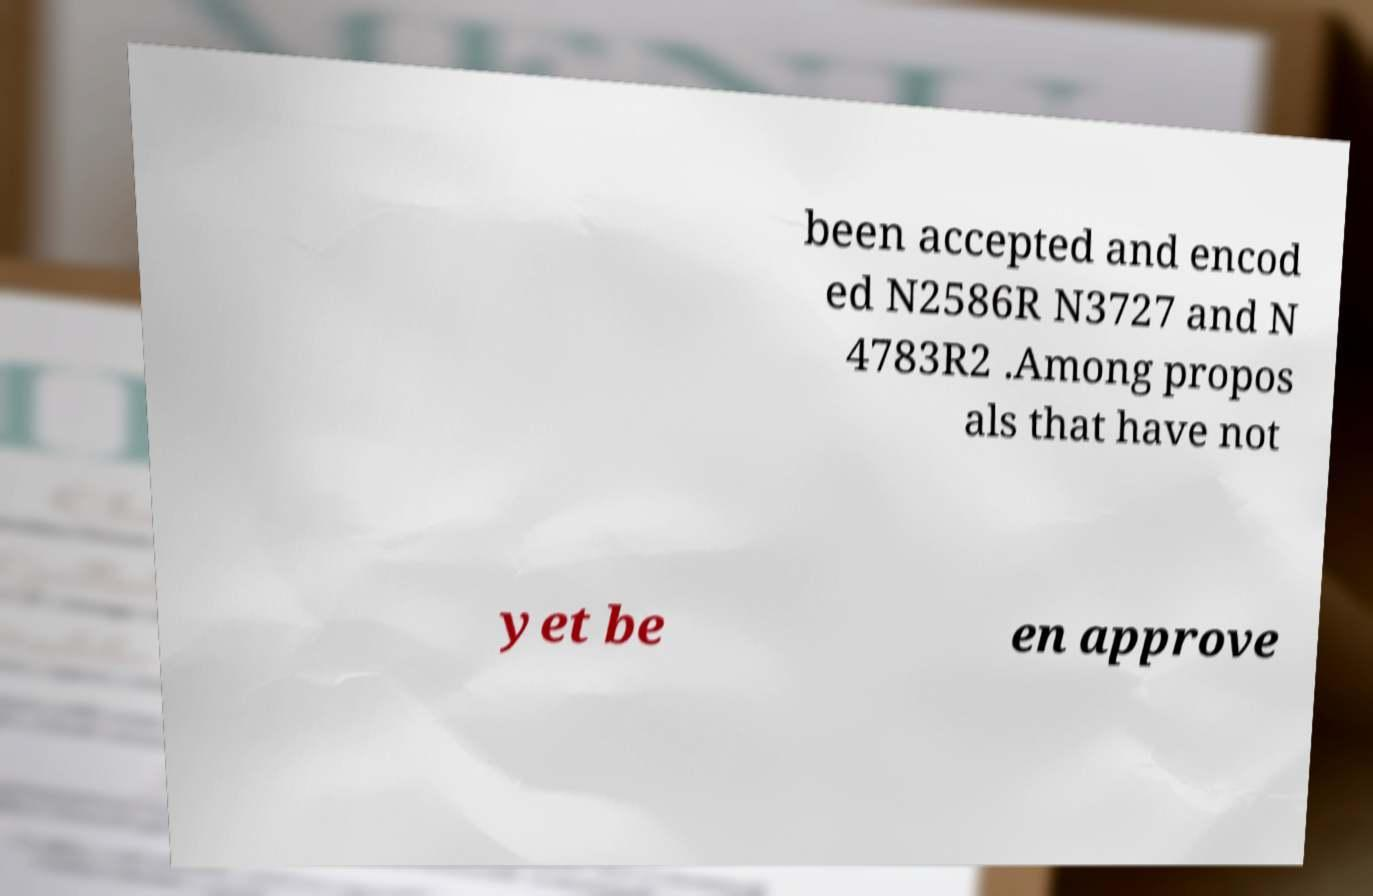Please identify and transcribe the text found in this image. been accepted and encod ed N2586R N3727 and N 4783R2 .Among propos als that have not yet be en approve 